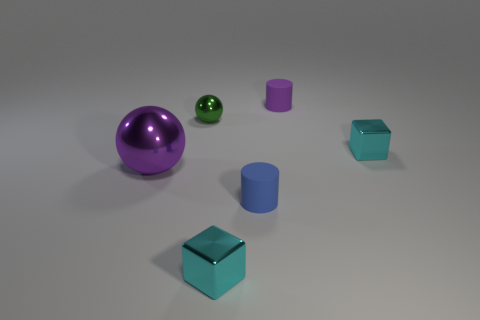Add 2 big gray rubber cylinders. How many objects exist? 8 Subtract all cylinders. How many objects are left? 4 Subtract 0 brown spheres. How many objects are left? 6 Subtract all tiny yellow cylinders. Subtract all cyan metal things. How many objects are left? 4 Add 5 tiny cyan blocks. How many tiny cyan blocks are left? 7 Add 4 brown things. How many brown things exist? 4 